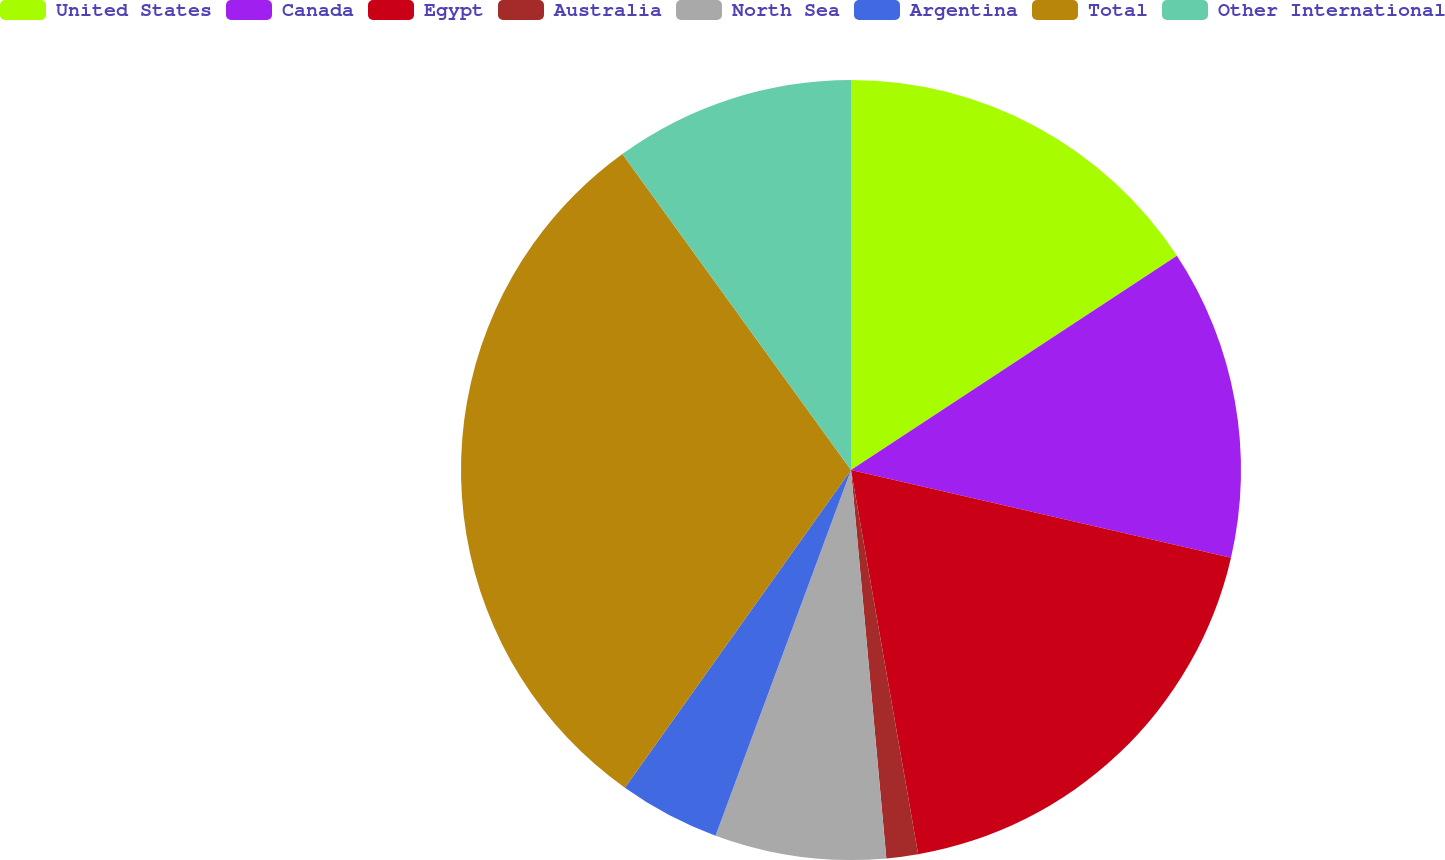Convert chart. <chart><loc_0><loc_0><loc_500><loc_500><pie_chart><fcel>United States<fcel>Canada<fcel>Egypt<fcel>Australia<fcel>North Sea<fcel>Argentina<fcel>Total<fcel>Other International<nl><fcel>15.75%<fcel>12.86%<fcel>18.64%<fcel>1.31%<fcel>7.09%<fcel>4.2%<fcel>30.19%<fcel>9.97%<nl></chart> 